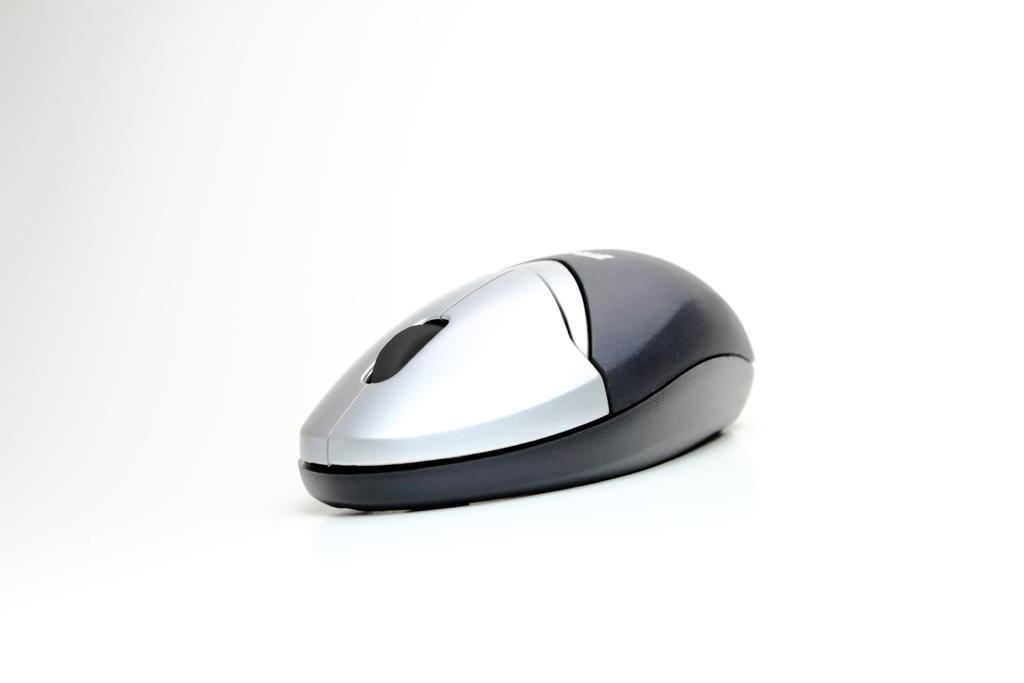What is the main subject of the image? There is a mouse in the image. What color is the background of the image? The background of the image is white. Can you describe the setting of the image? The image may have been taken in a room, as suggested by the white background. What type of slope can be seen in the image? There is no slope present in the image; it features a mouse and a white background. How many questions are visible in the image? There are no questions visible in the image; it features a mouse and a white background. 